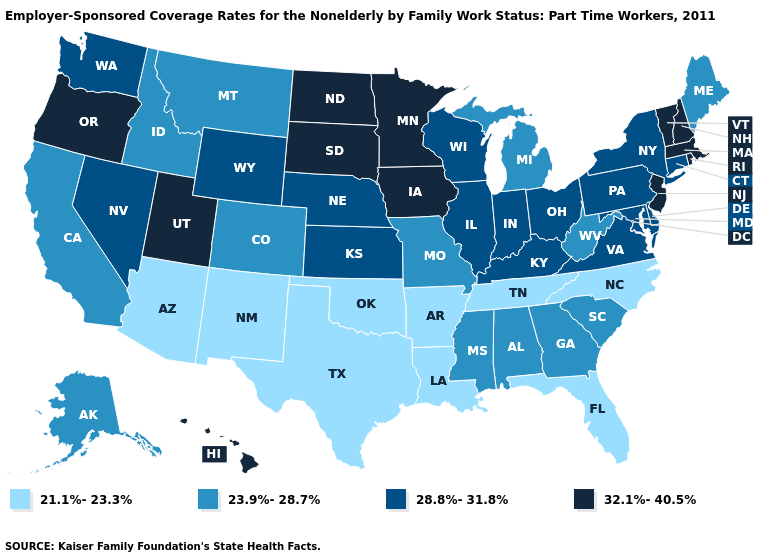What is the value of Minnesota?
Concise answer only. 32.1%-40.5%. Among the states that border Georgia , which have the highest value?
Keep it brief. Alabama, South Carolina. What is the value of Oklahoma?
Give a very brief answer. 21.1%-23.3%. Does Kentucky have a lower value than Montana?
Quick response, please. No. Which states hav the highest value in the West?
Give a very brief answer. Hawaii, Oregon, Utah. What is the lowest value in the West?
Keep it brief. 21.1%-23.3%. Does North Carolina have the lowest value in the South?
Be succinct. Yes. Does Nebraska have the lowest value in the USA?
Quick response, please. No. What is the highest value in the USA?
Quick response, please. 32.1%-40.5%. Name the states that have a value in the range 21.1%-23.3%?
Keep it brief. Arizona, Arkansas, Florida, Louisiana, New Mexico, North Carolina, Oklahoma, Tennessee, Texas. What is the value of Virginia?
Short answer required. 28.8%-31.8%. Does Michigan have the lowest value in the MidWest?
Write a very short answer. Yes. What is the value of New York?
Short answer required. 28.8%-31.8%. What is the highest value in states that border Pennsylvania?
Be succinct. 32.1%-40.5%. Does the first symbol in the legend represent the smallest category?
Write a very short answer. Yes. 